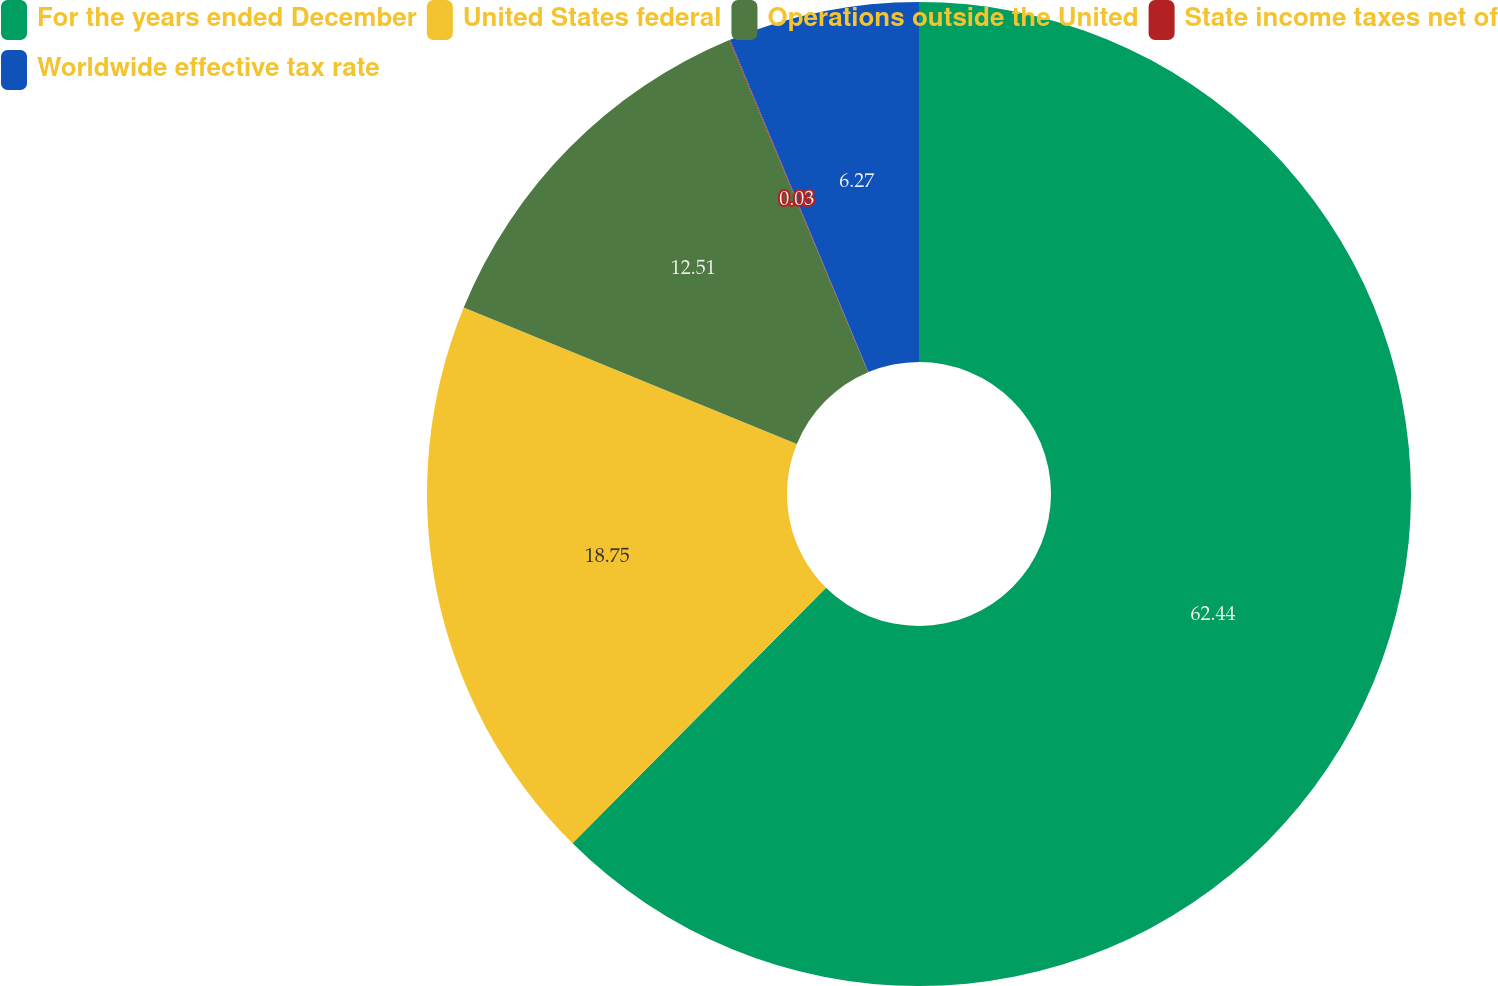Convert chart to OTSL. <chart><loc_0><loc_0><loc_500><loc_500><pie_chart><fcel>For the years ended December<fcel>United States federal<fcel>Operations outside the United<fcel>State income taxes net of<fcel>Worldwide effective tax rate<nl><fcel>62.43%<fcel>18.75%<fcel>12.51%<fcel>0.03%<fcel>6.27%<nl></chart> 